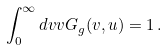<formula> <loc_0><loc_0><loc_500><loc_500>\int _ { 0 } ^ { \infty } d v v G _ { g } ( v , u ) = 1 \, .</formula> 